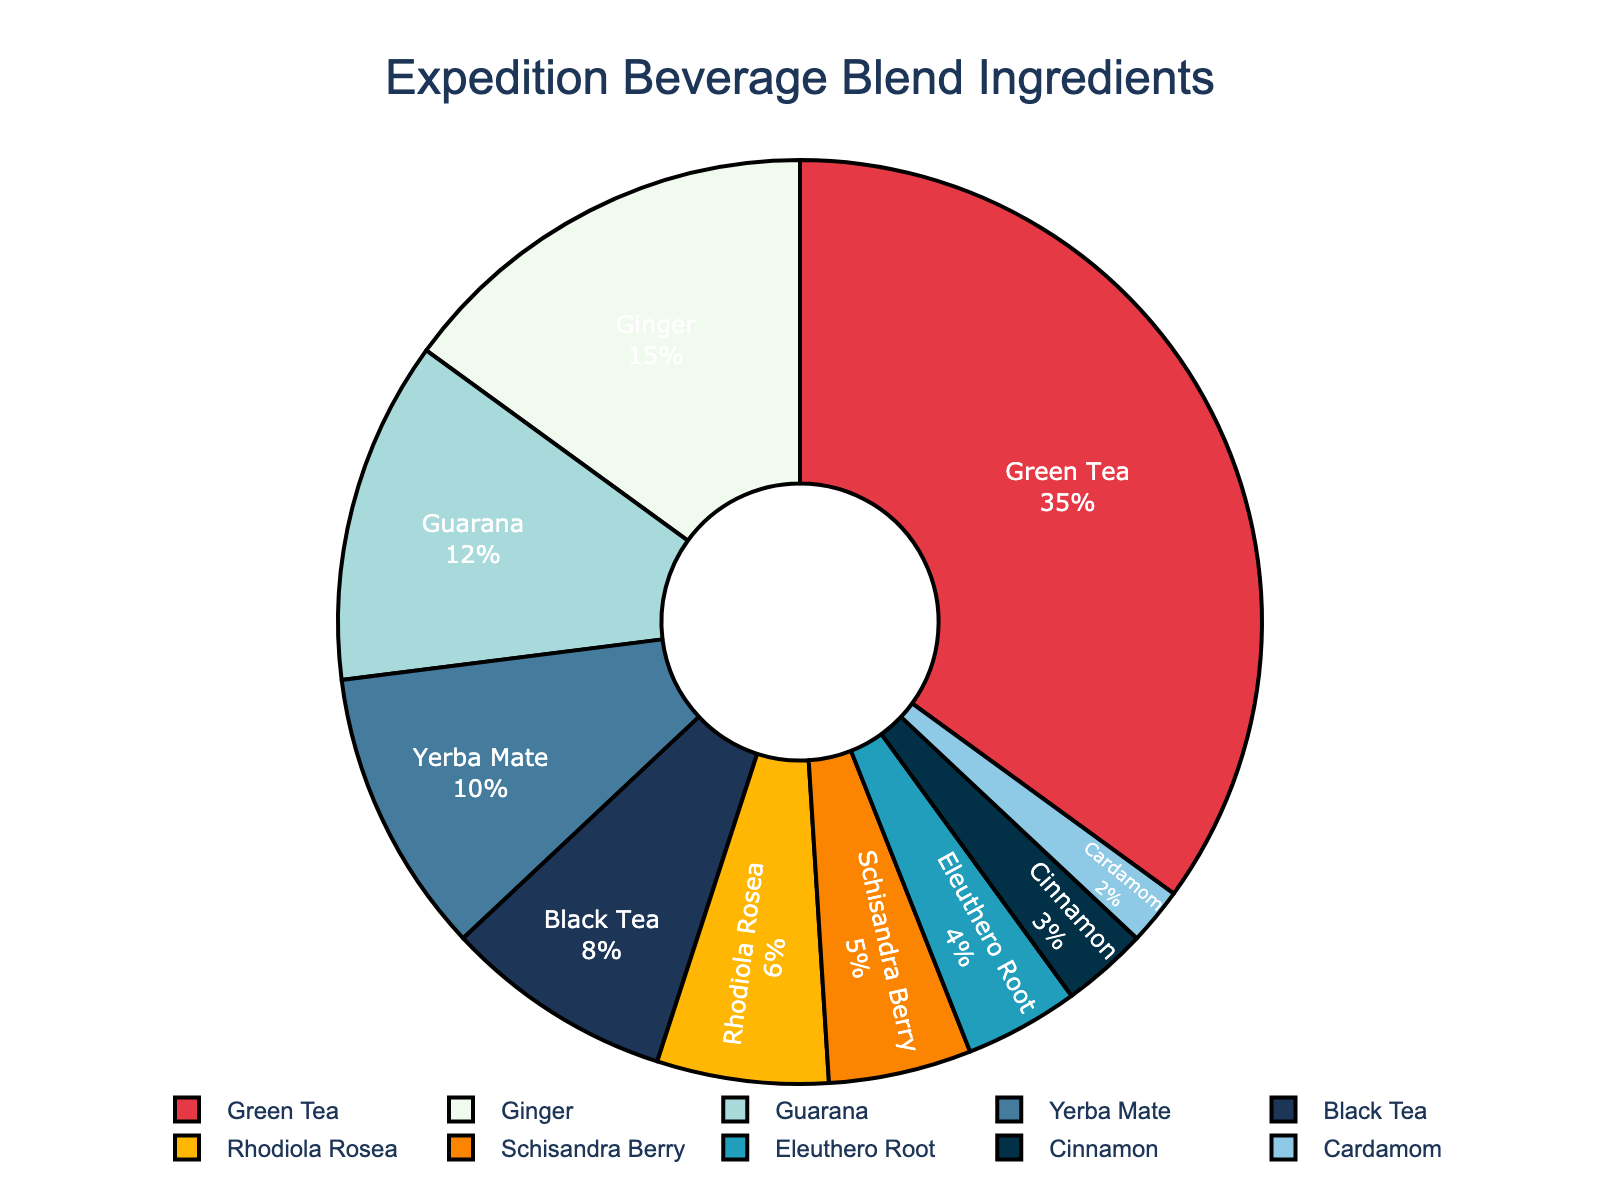Which ingredient has the highest proportion in the beverage blend? By visually observing the pie chart, we can quickly identify the segment with the largest area. The label inside the largest sector shows "Green Tea" with 35%.
Answer: Green Tea How much more is the proportion of Green Tea compared to Black Tea? The segment for Green Tea shows 35%, and the segment for Black Tea shows 8%. The difference can be calculated as 35% - 8% = 27%.
Answer: 27% What is the combined percentage of ingredients that have a proportion less than 5%? The ingredients with less than 5% are Schisandra Berry (5%), Eleuthero Root (4%), Cinnamon (3%), and Cardamom (2%). Adding these gives 5% + 4% + 3% + 2% = 14%.
Answer: 14% Which ingredient has the smallest proportion, and what is its percentage? The smallest segment in the pie chart, visually the narrowest slice, is for Cardamom, which shows 2%.
Answer: Cardamom, 2% What is the proportion of Yerba Mate in the beverage blend? By looking at the pie chart, we can identify the section labeled "Yerba Mate," which shows 10%.
Answer: 10% How do the proportions of Ginger and Guarana compare? Ginger has a proportion of 15%, and Guarana has a proportion of 12%. Clearly, Ginger has a higher proportion than Guarana.
Answer: Ginger is higher If you sum the proportions of Rhodiola Rosea and Black Tea, what is the result? Rhodiola Rosea has a proportion of 6%, and Black Tea has 8%. Adding these gives 6% + 8% = 14%.
Answer: 14% Which ingredient(s) together make up over 60% of the beverage blend? Adding the proportions of the largest segments one by one until it exceeds 60%, we get Green Tea (35%) + Ginger (15%) = 50%, then adding Guarana (12%) gives a total of 62%. The ingredients are Green Tea, Ginger, and Guarana.
Answer: Green Tea, Ginger, Guarana Which ingredient's proportion is closest to the average proportion of all ingredients? There are 10 ingredients. Summing up all their percentages: 35% + 15% + 12% + 10% + 8% + 6% + 5% + 4% + 3% + 2% = 100%, and dividing by 10 gives an average of 10%. Yerba Mate, with 10%, exactly matches the average.
Answer: Yerba Mate Between Rhodiola Rosea and Schisandra Berry, which one has a smaller percentage, and by how much? Rhodiola Rosea has a proportion of 6%, while Schisandra Berry has 5%. The difference is 6% - 5% = 1%.
Answer: Schisandra Berry, by 1% 